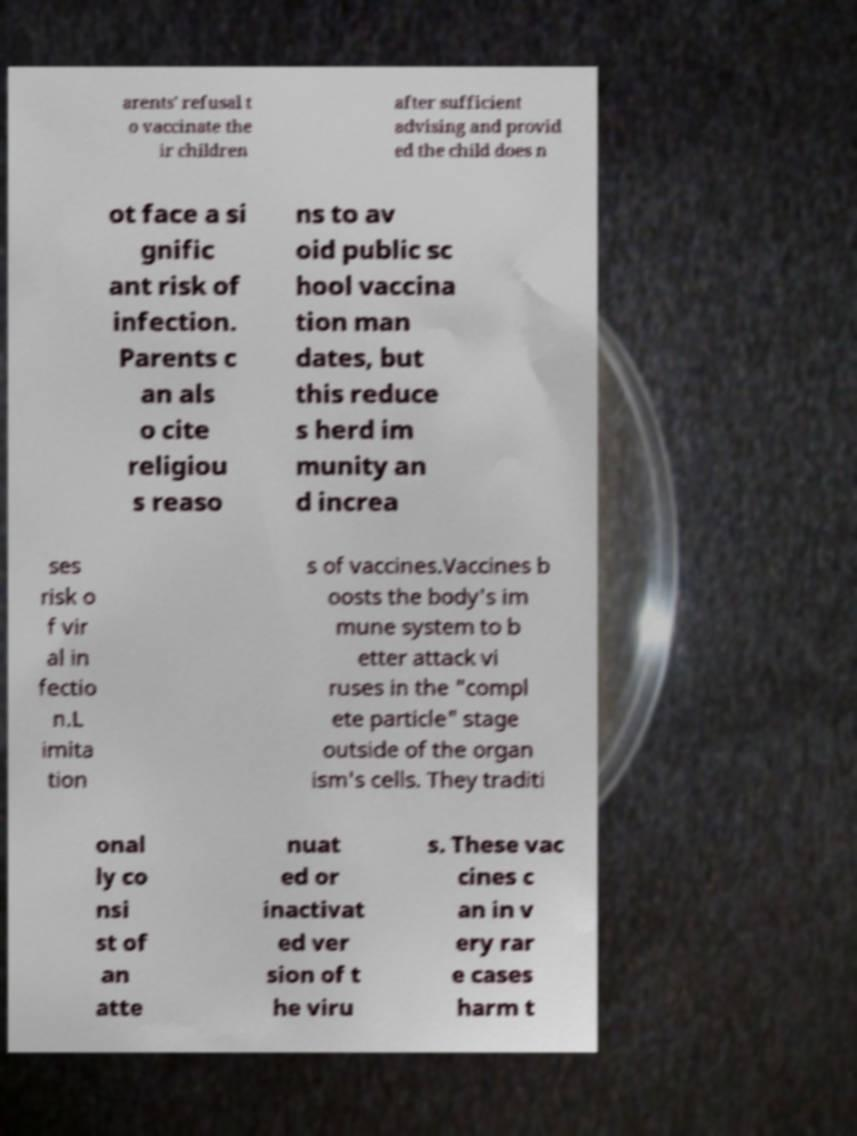I need the written content from this picture converted into text. Can you do that? arents' refusal t o vaccinate the ir children after sufficient advising and provid ed the child does n ot face a si gnific ant risk of infection. Parents c an als o cite religiou s reaso ns to av oid public sc hool vaccina tion man dates, but this reduce s herd im munity an d increa ses risk o f vir al in fectio n.L imita tion s of vaccines.Vaccines b oosts the body's im mune system to b etter attack vi ruses in the "compl ete particle" stage outside of the organ ism's cells. They traditi onal ly co nsi st of an atte nuat ed or inactivat ed ver sion of t he viru s. These vac cines c an in v ery rar e cases harm t 